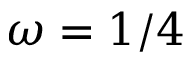Convert formula to latex. <formula><loc_0><loc_0><loc_500><loc_500>\omega = 1 / 4</formula> 